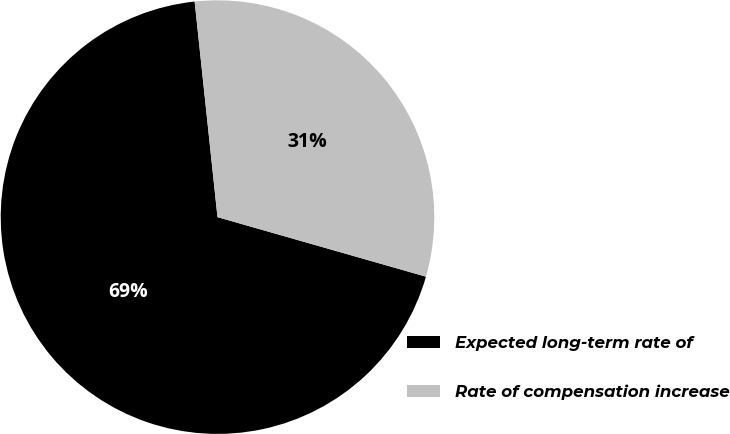Convert chart. <chart><loc_0><loc_0><loc_500><loc_500><pie_chart><fcel>Expected long-term rate of<fcel>Rate of compensation increase<nl><fcel>68.89%<fcel>31.11%<nl></chart> 